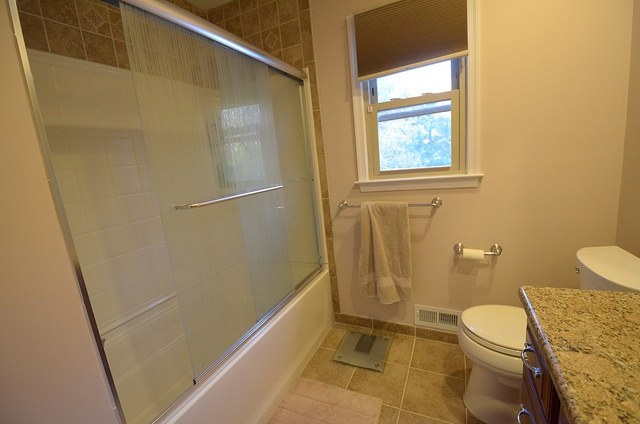Describe the objects in this image and their specific colors. I can see a toilet in gray, tan, and maroon tones in this image. 